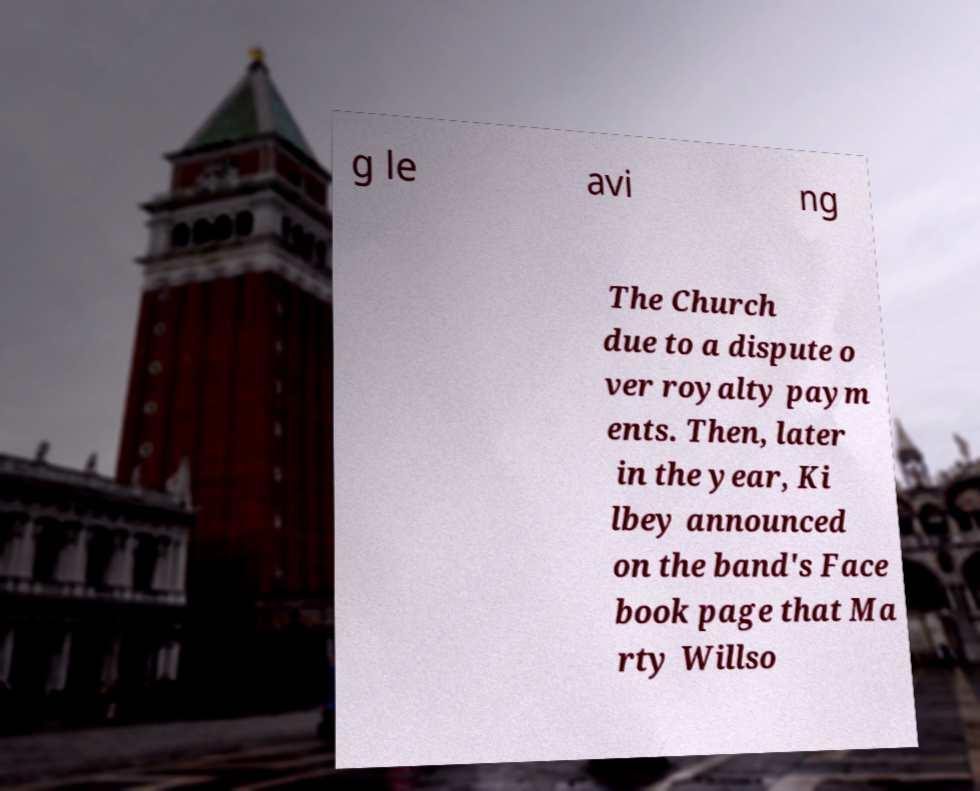Can you read and provide the text displayed in the image?This photo seems to have some interesting text. Can you extract and type it out for me? g le avi ng The Church due to a dispute o ver royalty paym ents. Then, later in the year, Ki lbey announced on the band's Face book page that Ma rty Willso 